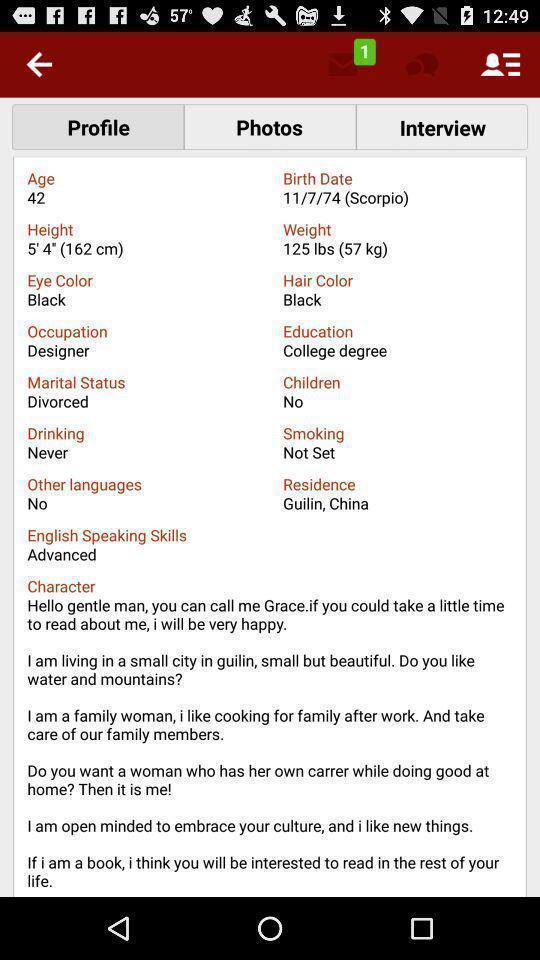Give me a summary of this screen capture. Profile page displaying. 